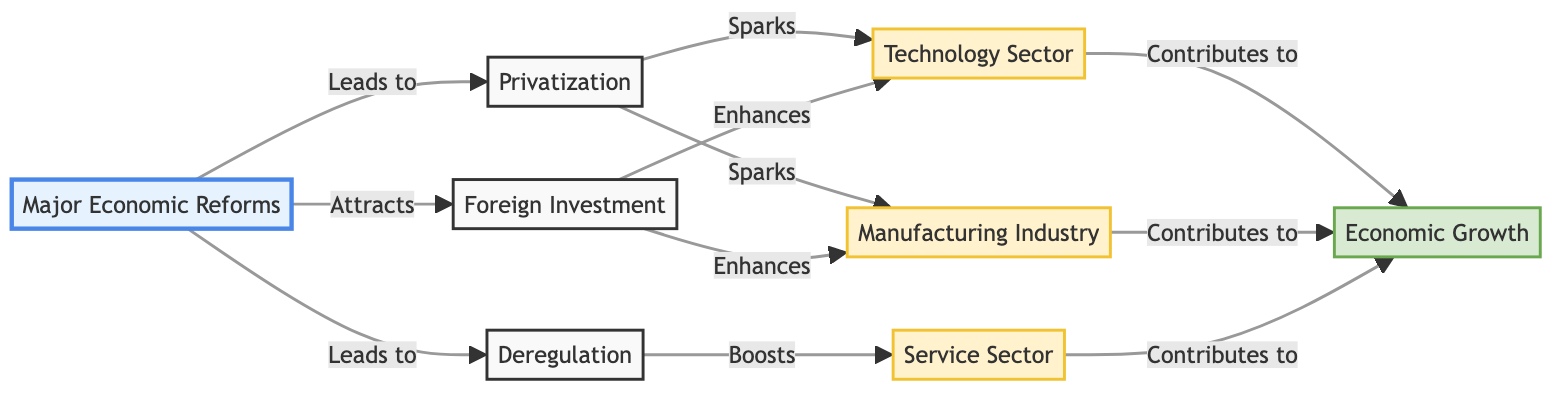What are the three primary nodes connected to "Major Economic Reforms"? The diagram shows three edges leading from "Major Economic Reforms" to "Privatization," "Deregulation," and "Foreign Investment." Therefore, these are the three primary nodes connected to it.
Answer: Privatization, Deregulation, Foreign Investment How many edges are in the diagram? The diagram includes multiple connections, and by counting each directed line (edge), we find that there are a total of 11 edges.
Answer: 11 What does "Privatization" spark? From the diagram, "Privatization" directly leads to "Technology Sector" and "Manufacturing Industry," both of which are labeled as being sparked by "Privatization."
Answer: Technology Sector, Manufacturing Industry Which node is boosted by "Deregulation"? The edge from "Deregulation" clearly indicates a directed relationship to the "Service Sector," meaning this node is boosted by it.
Answer: Service Sector Which market sector contributes the most to economic growth, according to the diagram? The diagram indicates that "Technology Sector," "Manufacturing Industry," and "Service Sector" all contribute to "Economic Growth." Hence, no single market sector is indicated as the most; they equally contribute.
Answer: Technology Sector, Manufacturing Industry, Service Sector What is the relationship between "Foreign Investment" and the "Technology Sector"? The diagram shows a directed edge from "Foreign Investment" to "Technology Sector," which is labeled as "Enhances," indicating that Foreign Investment has a positive effect on the Technology Sector.
Answer: Enhances How many nodes are classified as sectors in the diagram? The nodes that are classified specifically as sectors according to the labels and types are "Technology Sector," "Manufacturing Industry," and "Service Sector," totaling three distinct sector nodes.
Answer: 3 What are the outcomes of the connections between "Economic Reforms" and "Economic Growth"? To determine this, we analyze the directed relationships: "Economic Growth" is contributed to by "Technology Sector," "Manufacturing Industry," and "Service Sector," all of which originate from the reforms. Thus, the reform has multiple pathways to influence economic growth.
Answer: Technology Sector, Manufacturing Industry, Service Sector 